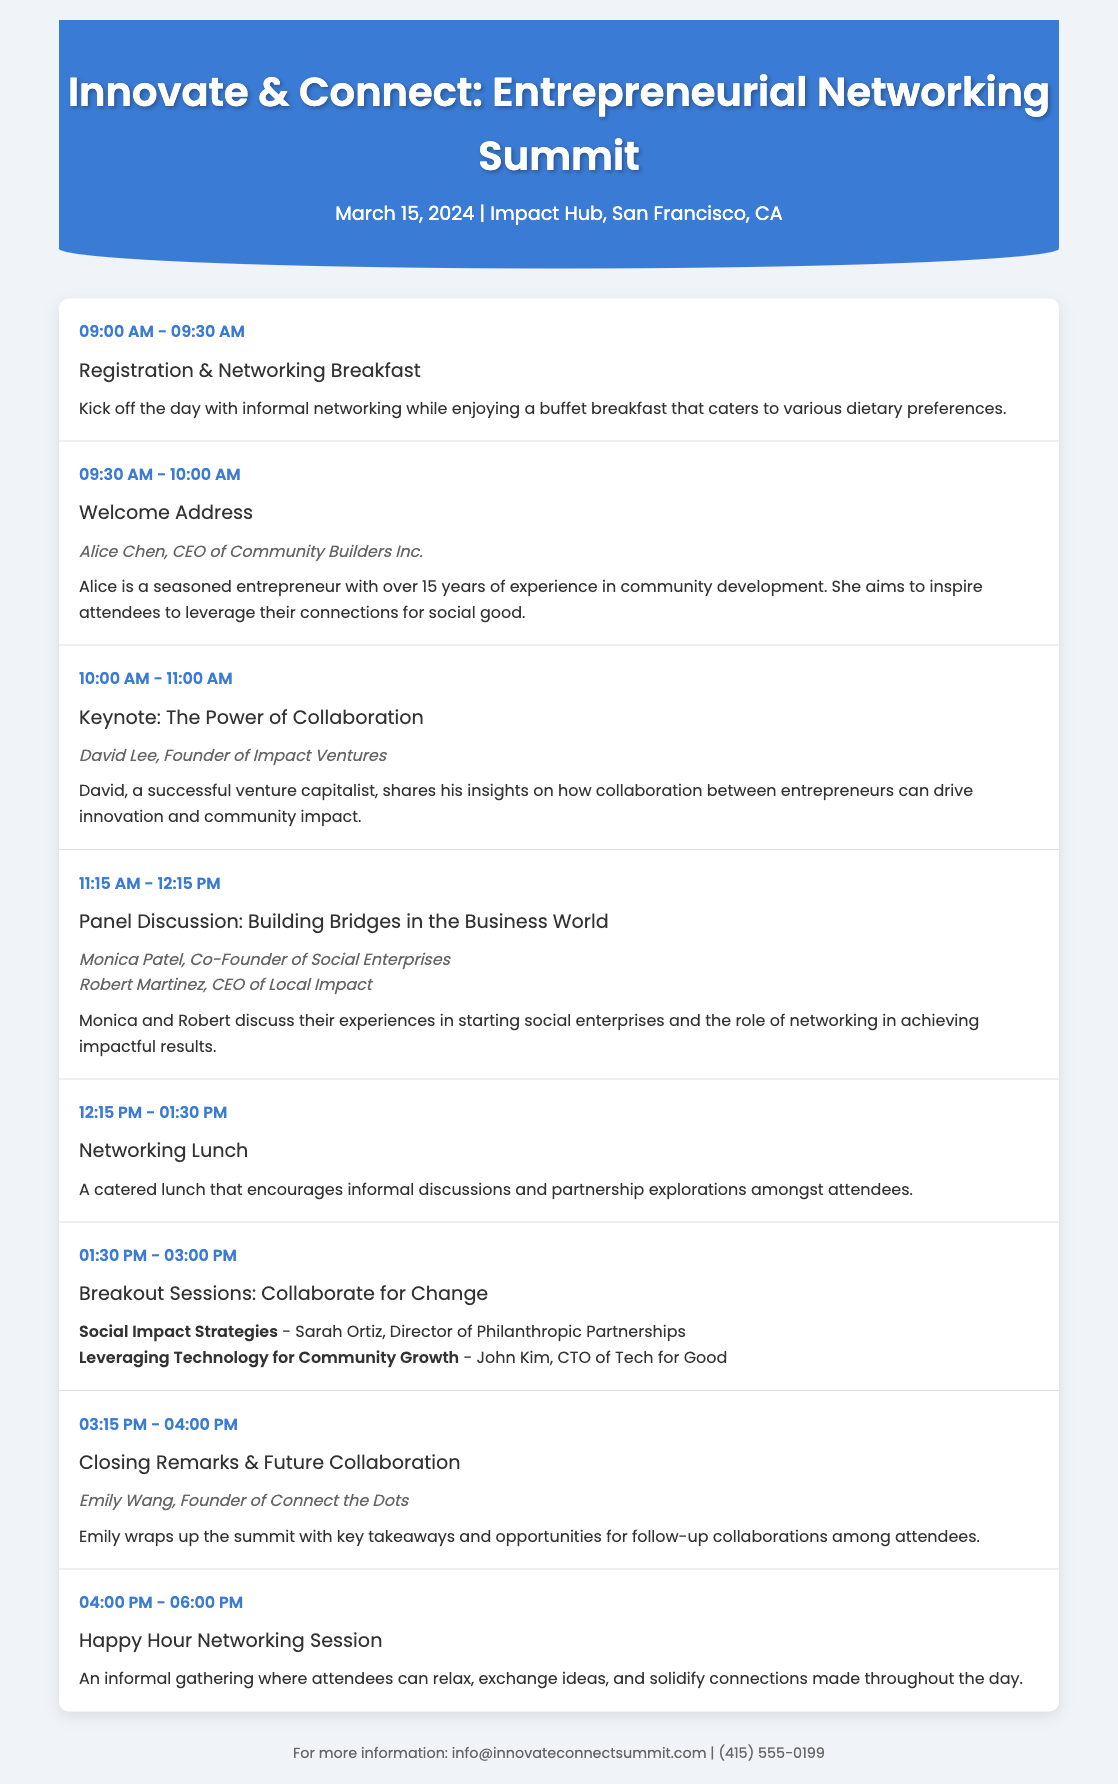What is the date of the event? The date of the event is mentioned in the document as March 15, 2024.
Answer: March 15, 2024 Who is the speaker for the Welcome Address? The speaker for the Welcome Address is listed in the agenda as Alice Chen, CEO of Community Builders Inc.
Answer: Alice Chen, CEO of Community Builders Inc What time does the Keynote session start? The start time for the Keynote session is provided in the agenda as 10:00 AM.
Answer: 10:00 AM How long is the Networking Lunch scheduled for? The duration of the Networking Lunch can be found in the agenda; it is scheduled from 12:15 PM to 01:30 PM, making it 1 hour and 15 minutes long.
Answer: 1 hour 15 minutes Which session involves a panel discussion? The session specifically outlined as a panel discussion in the agenda is "Building Bridges in the Business World."
Answer: Building Bridges in the Business World Who will give the closing remarks? The speaker giving closing remarks is listed in the agenda as Emily Wang, Founder of Connect the Dots.
Answer: Emily Wang, Founder of Connect the Dots What is the main focus of the Breakout Sessions? The description of the Breakout Sessions indicates their main focus as collaborating for change.
Answer: Collaborate for Change What type of meal is provided during the Registration & Networking Breakfast? The document states that the breakfast includes a buffet catering to various dietary preferences.
Answer: Buffet breakfast 